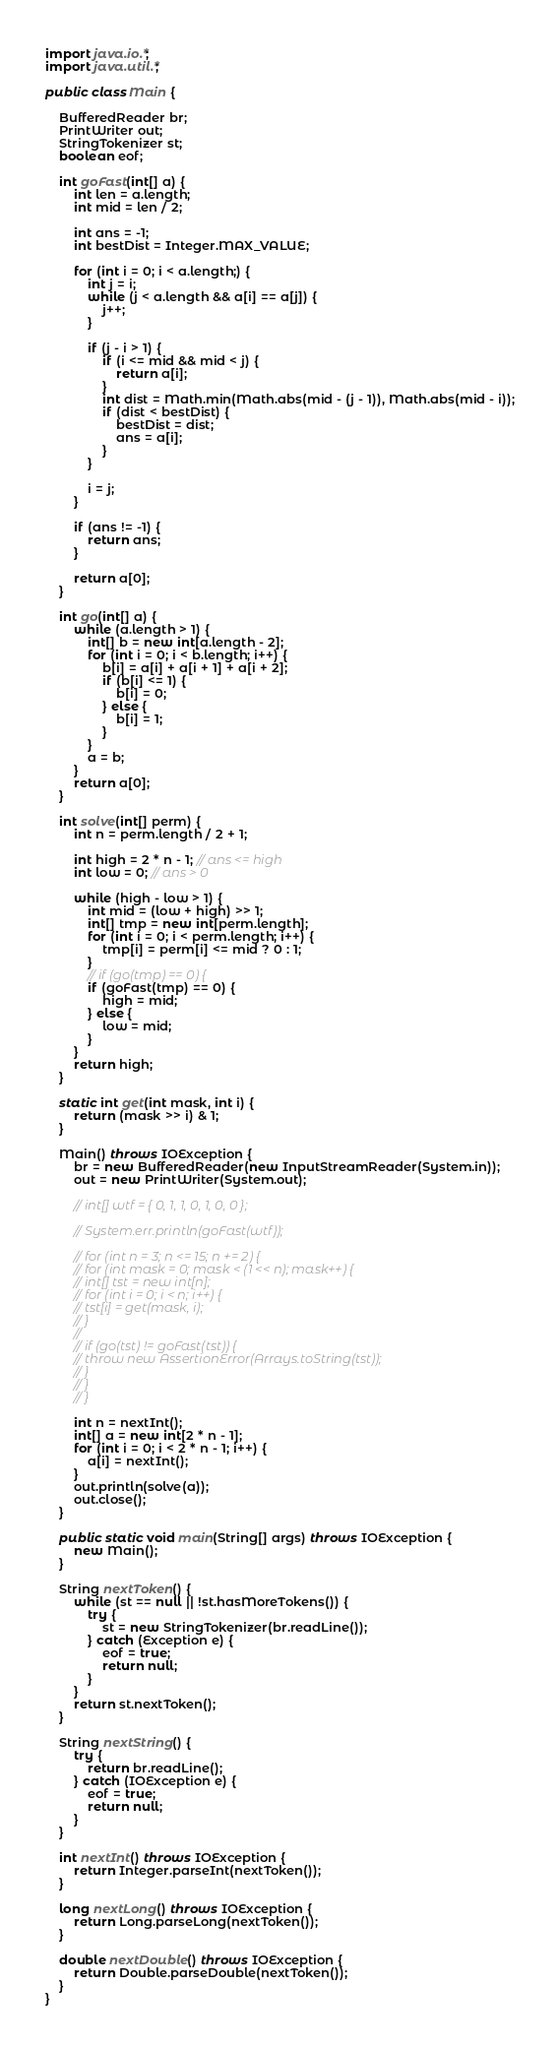Convert code to text. <code><loc_0><loc_0><loc_500><loc_500><_Java_>import java.io.*;
import java.util.*;

public class Main {

	BufferedReader br;
	PrintWriter out;
	StringTokenizer st;
	boolean eof;

	int goFast(int[] a) {
		int len = a.length;
		int mid = len / 2;

		int ans = -1;
		int bestDist = Integer.MAX_VALUE;

		for (int i = 0; i < a.length;) {
			int j = i;
			while (j < a.length && a[i] == a[j]) {
				j++;
			}

			if (j - i > 1) {
				if (i <= mid && mid < j) {
					return a[i];
				}
				int dist = Math.min(Math.abs(mid - (j - 1)), Math.abs(mid - i));
				if (dist < bestDist) {
					bestDist = dist;
					ans = a[i];
				}
			}

			i = j;
		}

		if (ans != -1) {
			return ans;
		}

		return a[0];
	}

	int go(int[] a) {
		while (a.length > 1) {
			int[] b = new int[a.length - 2];
			for (int i = 0; i < b.length; i++) {
				b[i] = a[i] + a[i + 1] + a[i + 2];
				if (b[i] <= 1) {
					b[i] = 0;
				} else {
					b[i] = 1;
				}
			}
			a = b;
		}
		return a[0];
	}

	int solve(int[] perm) {
		int n = perm.length / 2 + 1;

		int high = 2 * n - 1; // ans <= high
		int low = 0; // ans > 0

		while (high - low > 1) {
			int mid = (low + high) >> 1;
			int[] tmp = new int[perm.length];
			for (int i = 0; i < perm.length; i++) {
				tmp[i] = perm[i] <= mid ? 0 : 1;
			}
			// if (go(tmp) == 0) {
			if (goFast(tmp) == 0) {
				high = mid;
			} else {
				low = mid;
			}
		}
		return high;
	}

	static int get(int mask, int i) {
		return (mask >> i) & 1;
	}

	Main() throws IOException {
		br = new BufferedReader(new InputStreamReader(System.in));
		out = new PrintWriter(System.out);

		// int[] wtf = { 0, 1, 1, 0, 1, 0, 0 };

		// System.err.println(goFast(wtf));

		// for (int n = 3; n <= 15; n += 2) {
		// for (int mask = 0; mask < (1 << n); mask++) {
		// int[] tst = new int[n];
		// for (int i = 0; i < n; i++) {
		// tst[i] = get(mask, i);
		// }
		//
		// if (go(tst) != goFast(tst)) {
		// throw new AssertionError(Arrays.toString(tst));
		// }
		// }
		// }

		int n = nextInt();
		int[] a = new int[2 * n - 1];
		for (int i = 0; i < 2 * n - 1; i++) {
			a[i] = nextInt();
		}
		out.println(solve(a));
		out.close();
	}

	public static void main(String[] args) throws IOException {
		new Main();
	}

	String nextToken() {
		while (st == null || !st.hasMoreTokens()) {
			try {
				st = new StringTokenizer(br.readLine());
			} catch (Exception e) {
				eof = true;
				return null;
			}
		}
		return st.nextToken();
	}

	String nextString() {
		try {
			return br.readLine();
		} catch (IOException e) {
			eof = true;
			return null;
		}
	}

	int nextInt() throws IOException {
		return Integer.parseInt(nextToken());
	}

	long nextLong() throws IOException {
		return Long.parseLong(nextToken());
	}

	double nextDouble() throws IOException {
		return Double.parseDouble(nextToken());
	}
}</code> 